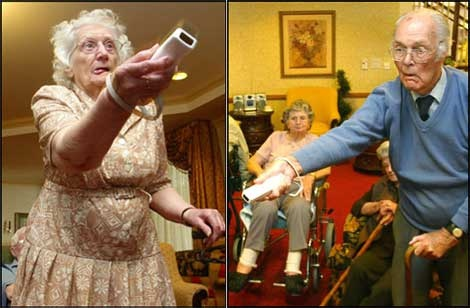Describe the objects in this image and their specific colors. I can see people in navy, tan, maroon, and gray tones, people in navy, black, gray, and blue tones, people in navy, tan, and gray tones, couch in navy, brown, maroon, and black tones, and chair in navy, black, maroon, and olive tones in this image. 